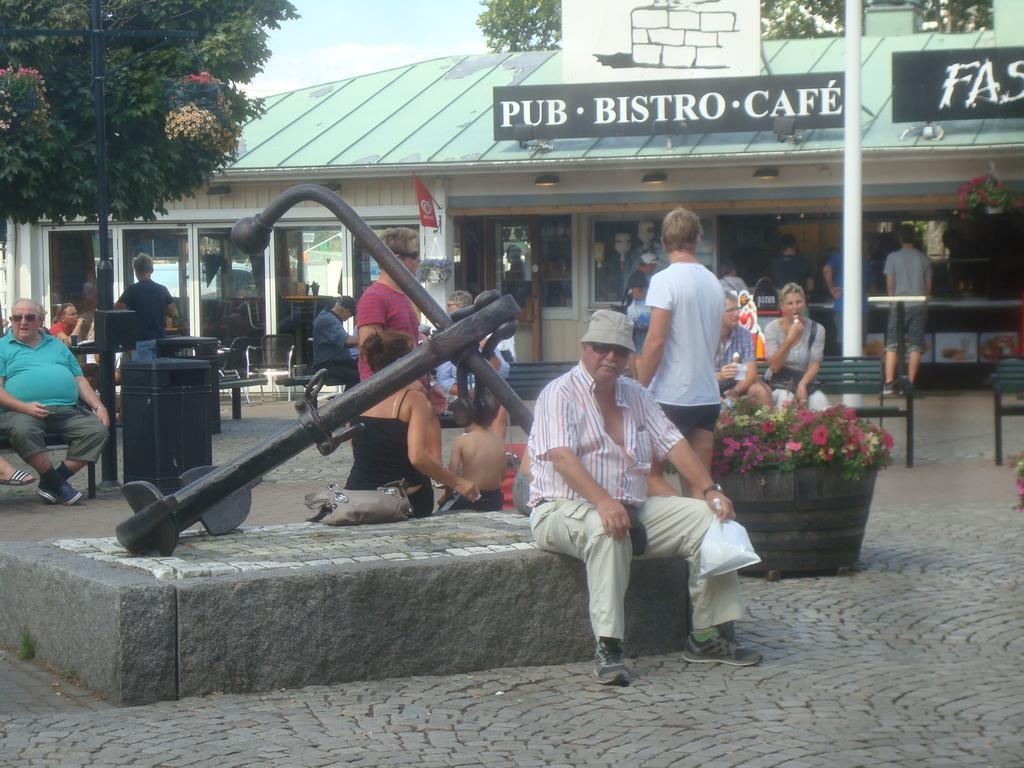Describe this image in one or two sentences. In the center of the image there is a person sitting wearing a hat. There are many persons in the image. In the background of the image there is a store. There are trees. At the bottom of the image there is road. 